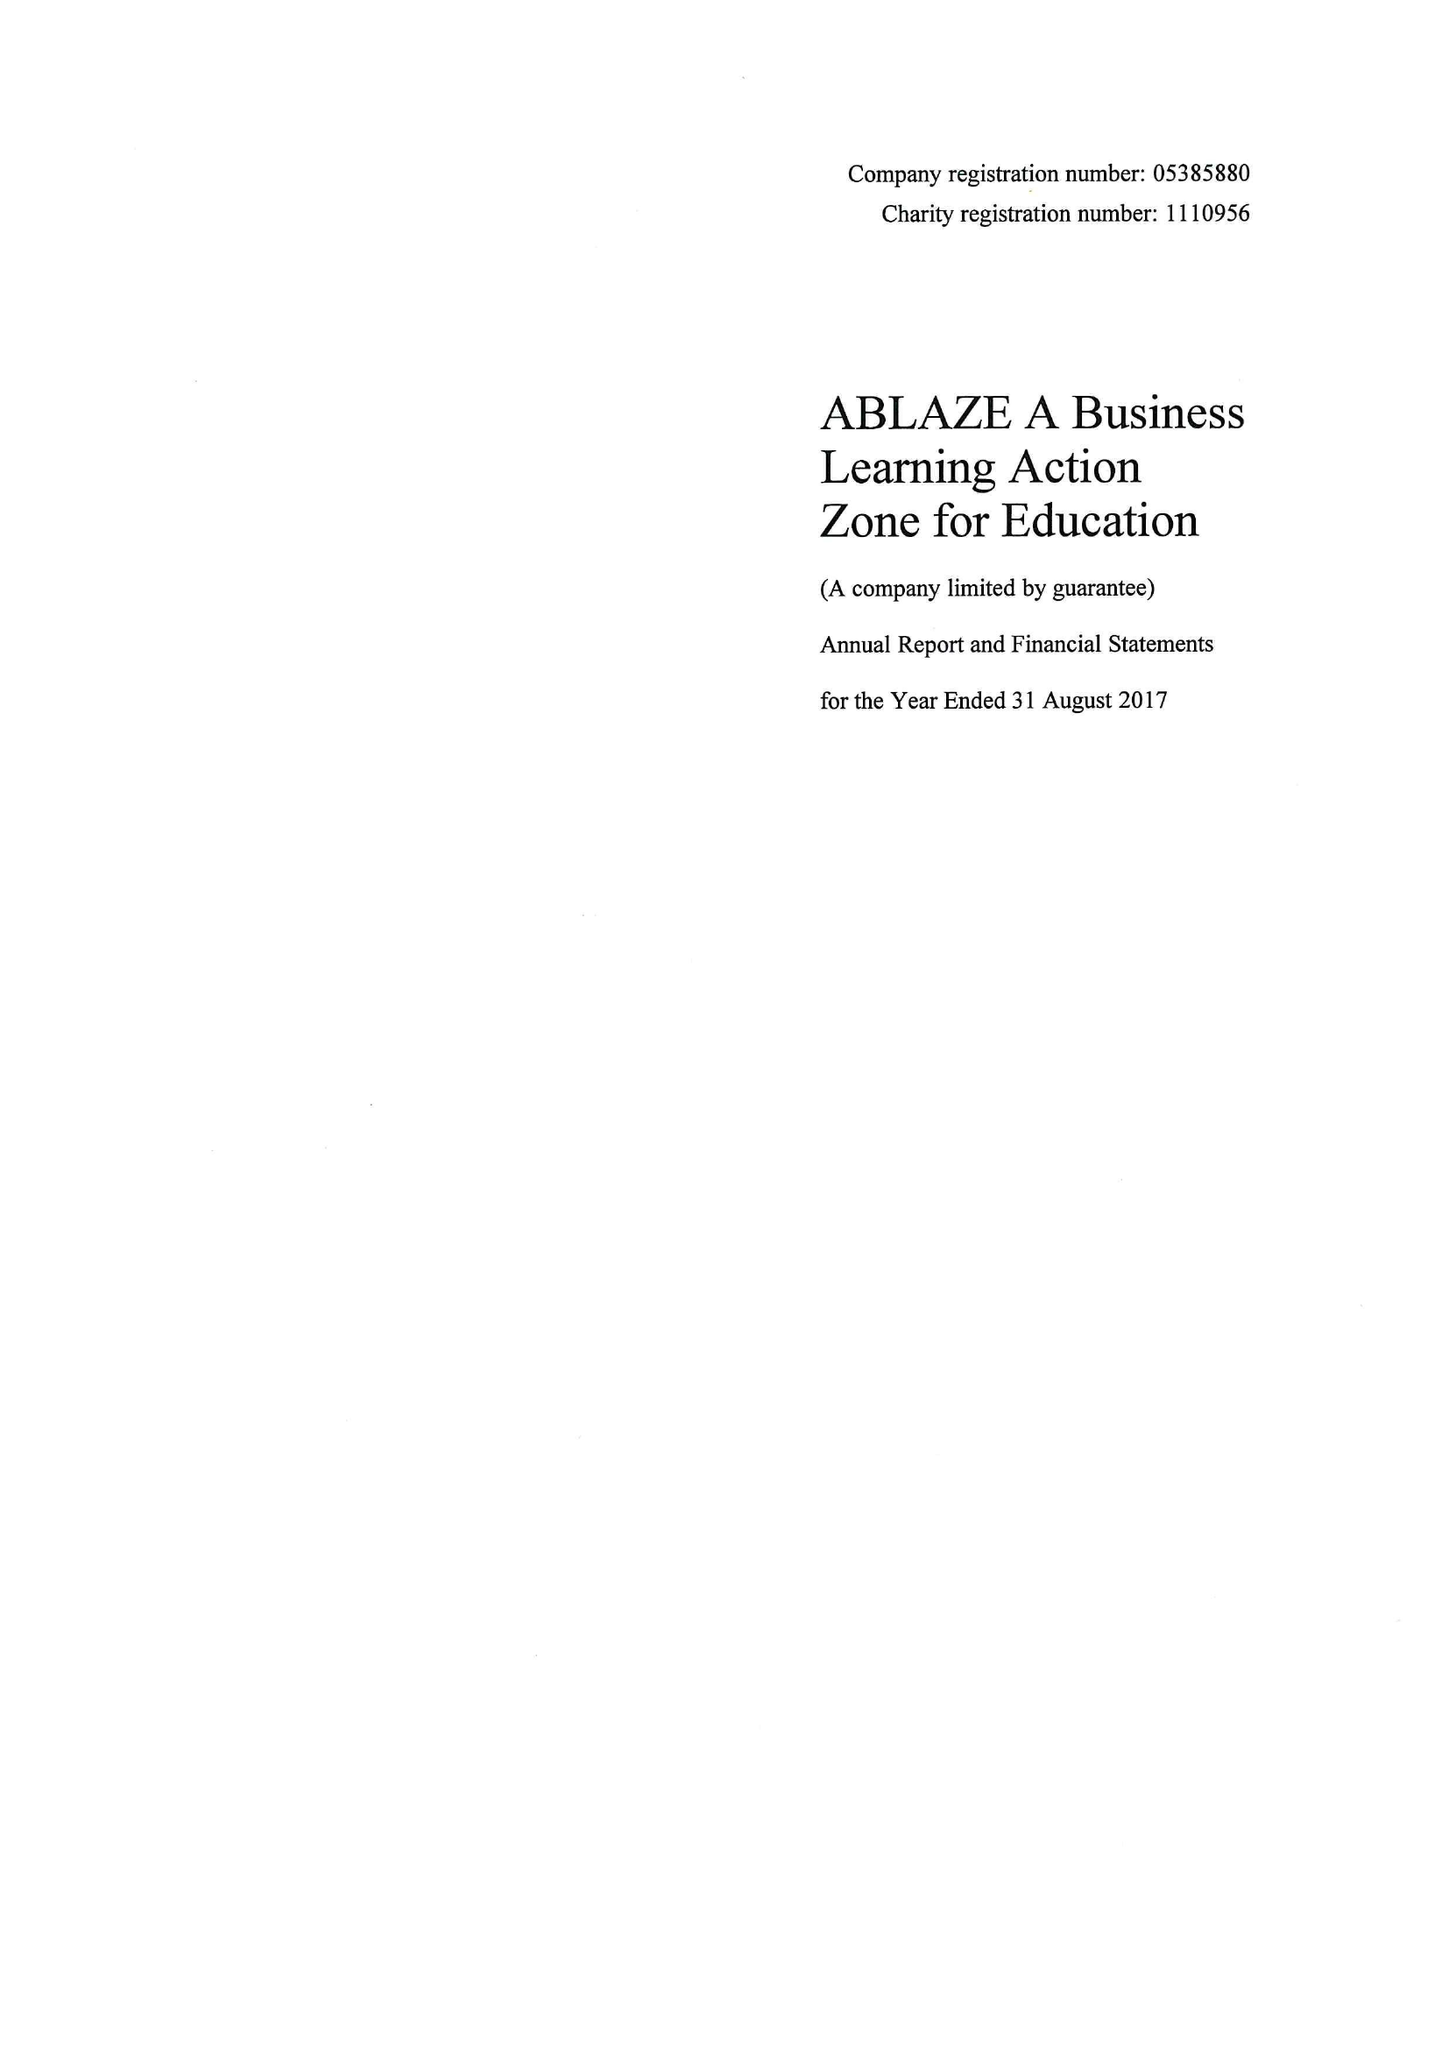What is the value for the address__postcode?
Answer the question using a single word or phrase. BS1 6NL 